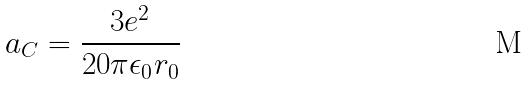<formula> <loc_0><loc_0><loc_500><loc_500>a _ { C } = \frac { 3 e ^ { 2 } } { 2 0 \pi \epsilon _ { 0 } r _ { 0 } }</formula> 